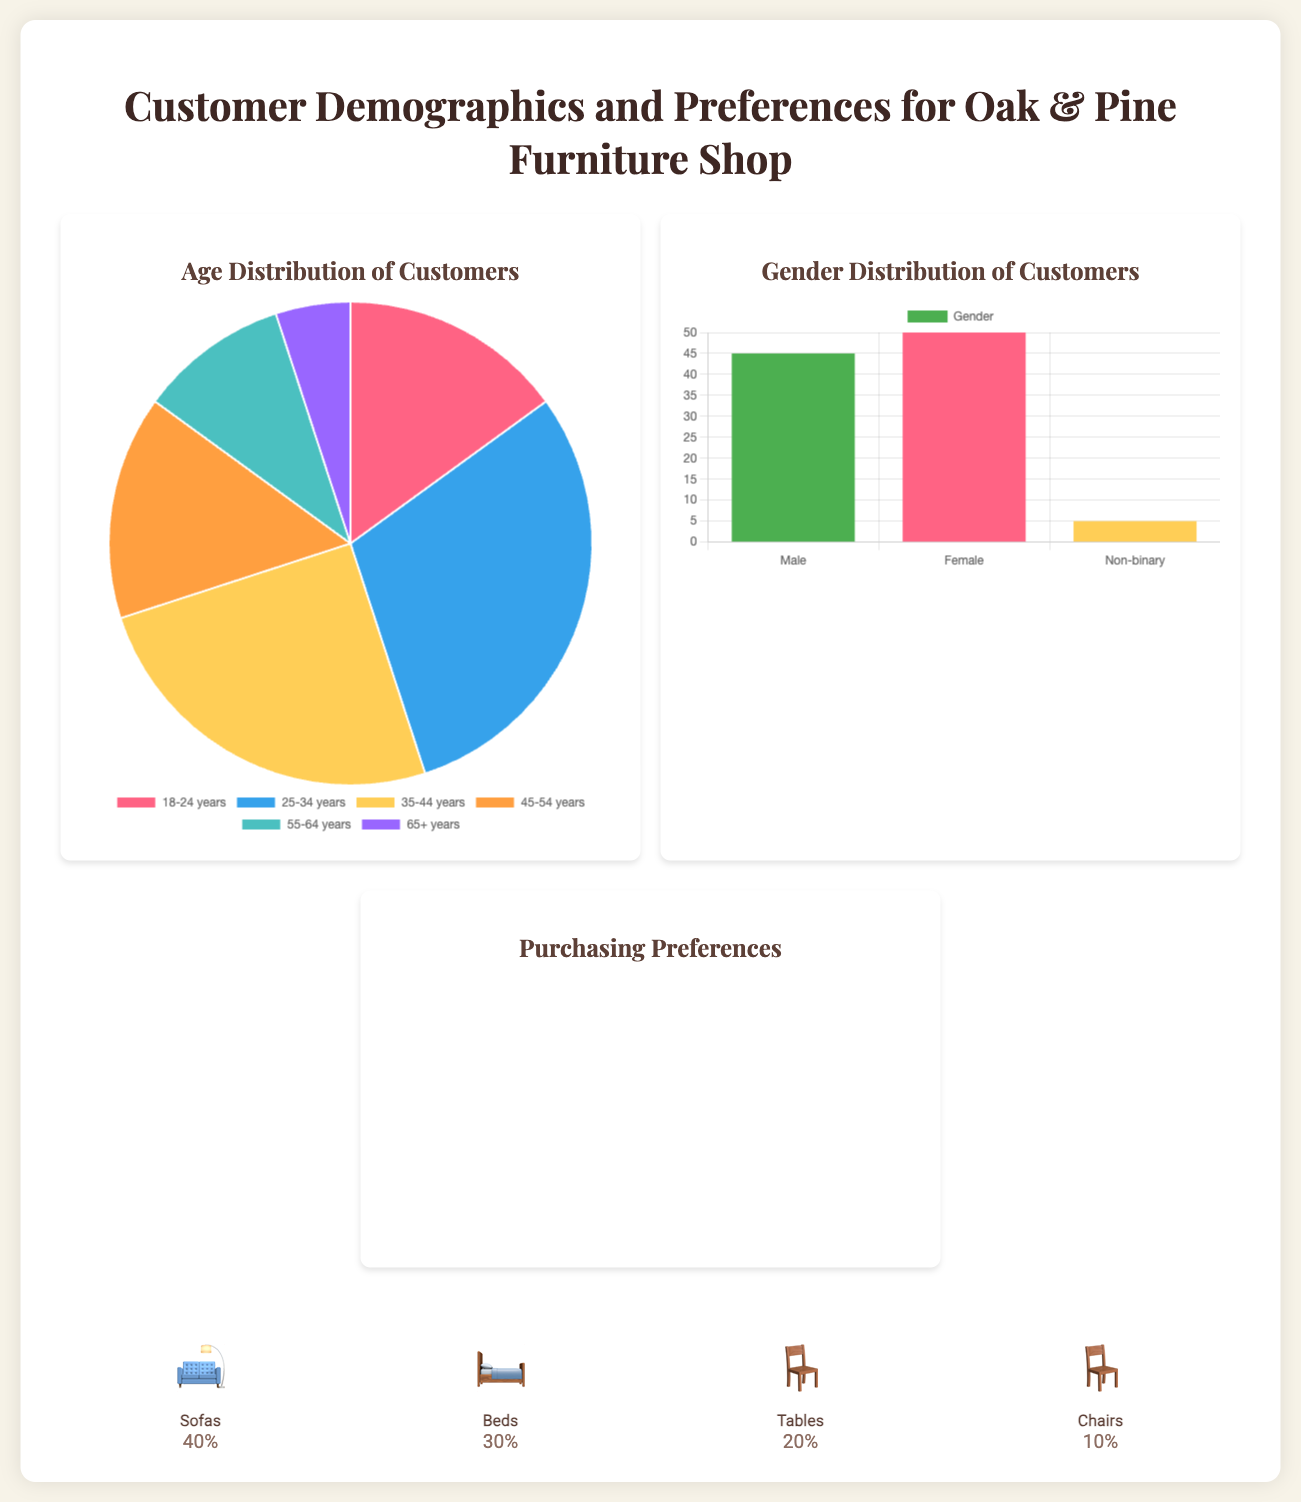What is the age group with the highest percentage of customers? The age distribution chart shows that the 25-34 years group has the highest percentage, at 30%.
Answer: 25-34 years What percentage of customers are Female? The gender distribution chart indicates that 50% of customers identify as Female.
Answer: 50% What is the percentage preference for Sofas among customers? In the icon section, it states that 40% of customers prefer Sofas.
Answer: 40% Which style preference has the least percentage? The horizontal bar chart shows that the Industrial style preference has the least percentage, at 5%.
Answer: Industrial What is the total percentage of customers aged 55 years and older? The age distribution chart shows that the combined percentage of customers aged 55-64 and 65+ years is 15%.
Answer: 15% What percentage of customers prefer Minimalist style? The horizontal bar chart indicates that 15% of customers prefer Minimalist style.
Answer: 15% What icon represents the Beds category in the document? The icon corresponding to the Beds category is represented by the bed emoji.
Answer: 🛏️ How many total segments are in the gender distribution? The gender distribution chart includes three segments: Male, Female, and Non-binary.
Answer: Three What color represents the preference for Rustic style? The Rustic style is represented by the color blue in the horizontal bar chart.
Answer: Blue 